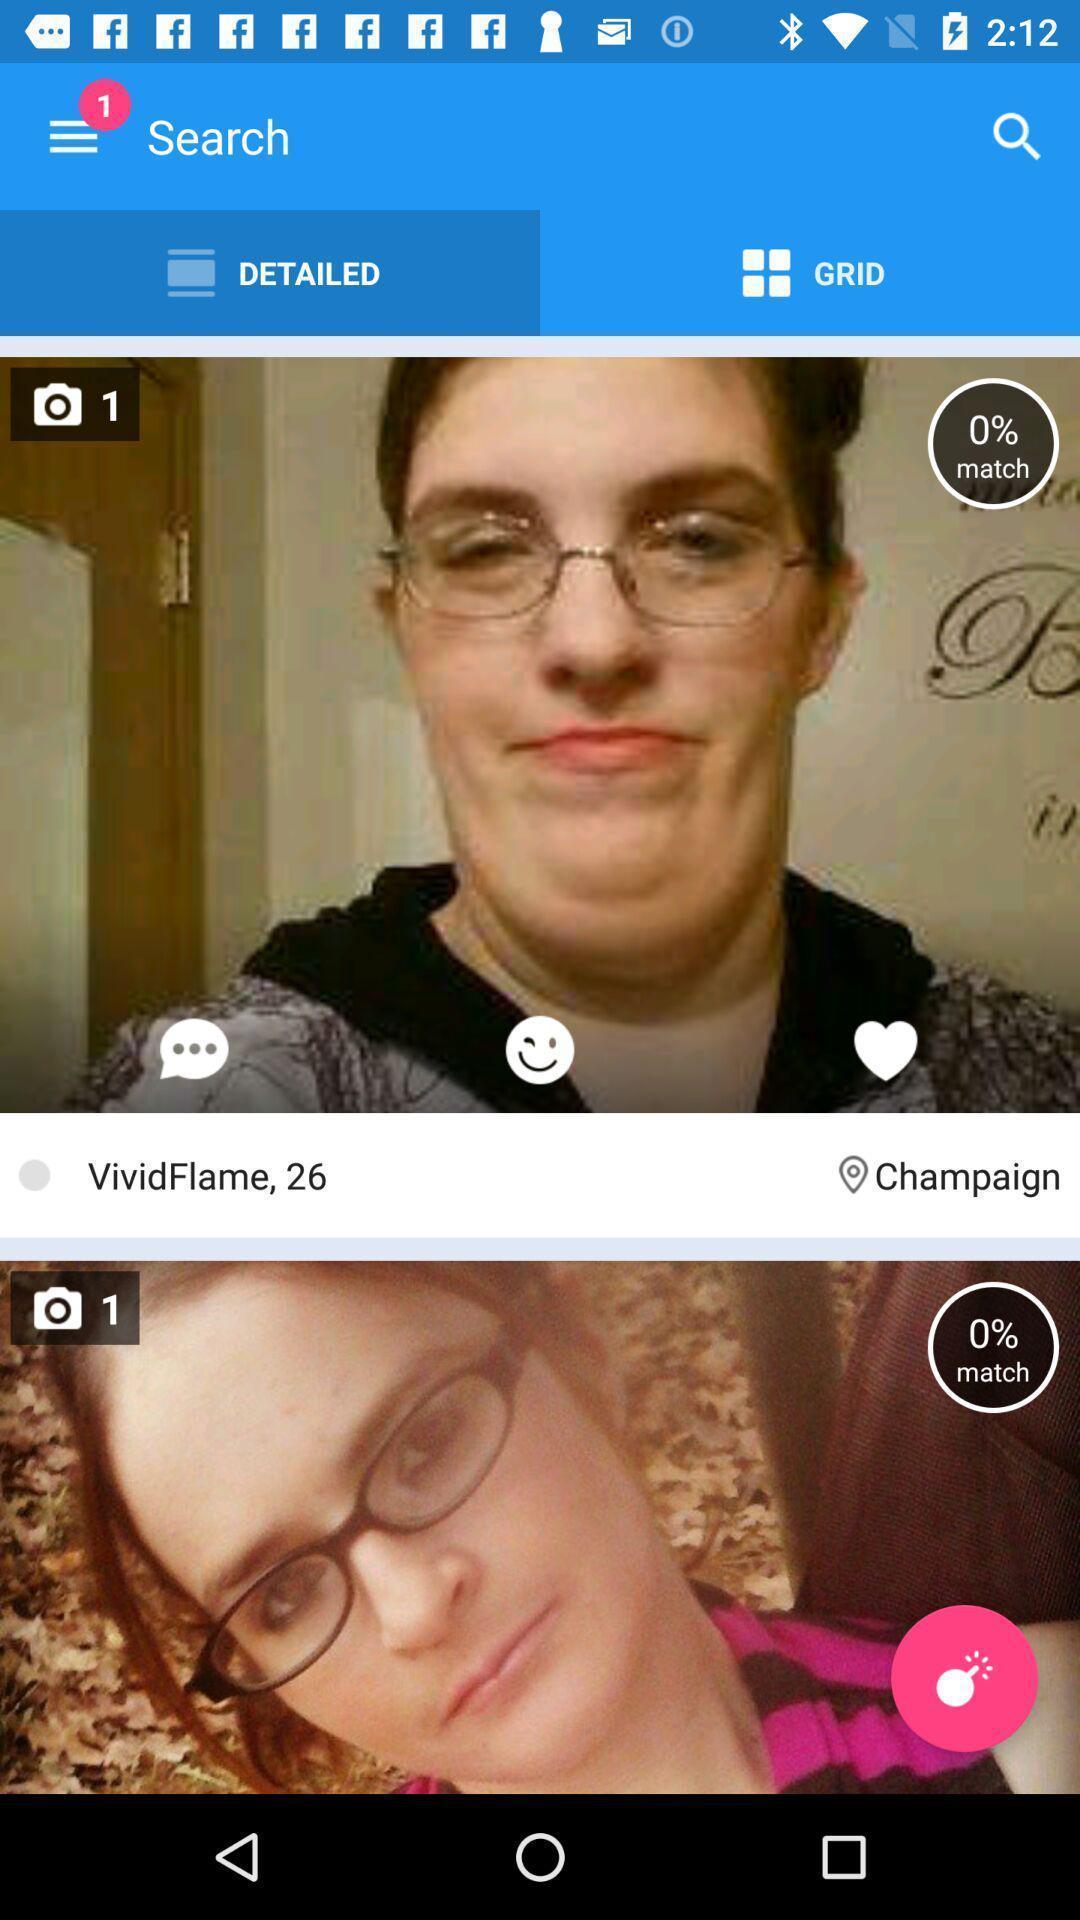Describe the key features of this screenshot. Page displaying search option. 